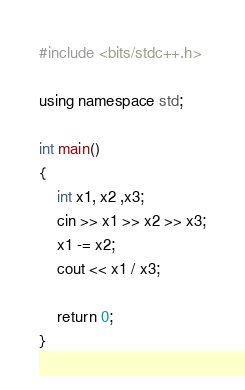Convert code to text. <code><loc_0><loc_0><loc_500><loc_500><_C++_>#include <bits/stdc++.h>

using namespace std;

int main()
{
    int x1, x2 ,x3;
    cin >> x1 >> x2 >> x3;
    x1 -= x2;
    cout << x1 / x3;

    return 0;
}</code> 